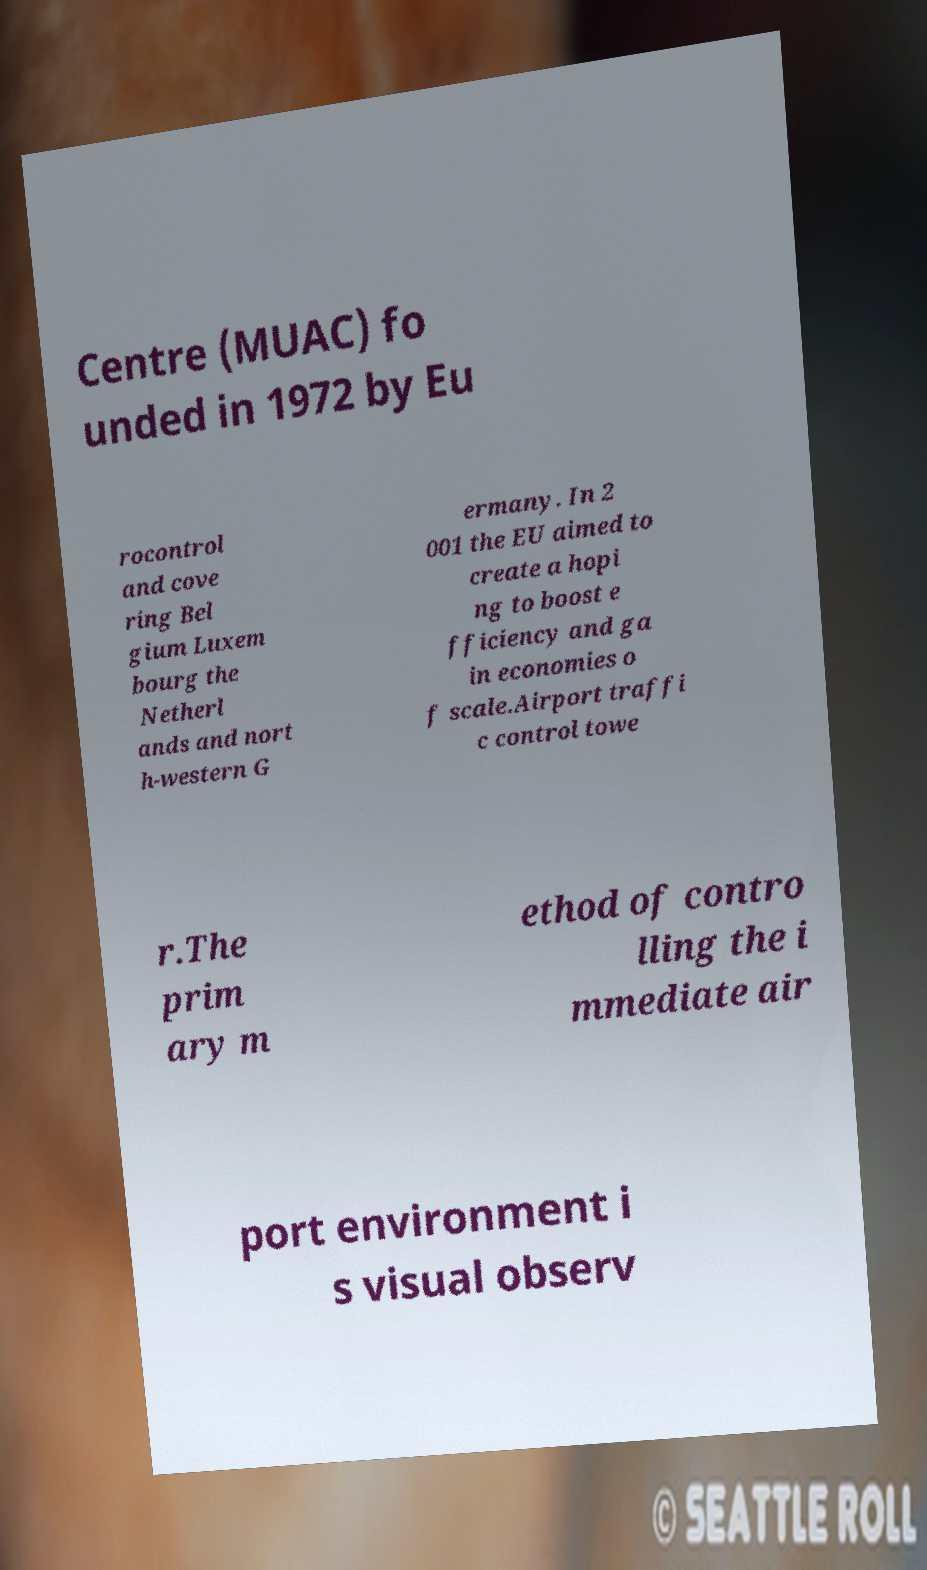For documentation purposes, I need the text within this image transcribed. Could you provide that? Centre (MUAC) fo unded in 1972 by Eu rocontrol and cove ring Bel gium Luxem bourg the Netherl ands and nort h-western G ermany. In 2 001 the EU aimed to create a hopi ng to boost e fficiency and ga in economies o f scale.Airport traffi c control towe r.The prim ary m ethod of contro lling the i mmediate air port environment i s visual observ 